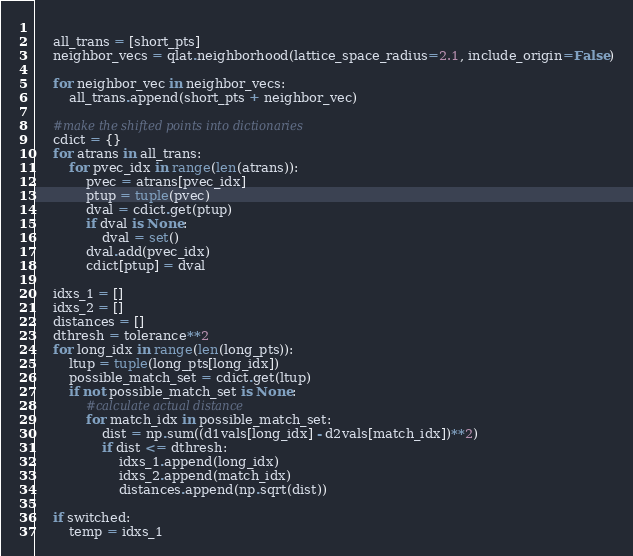<code> <loc_0><loc_0><loc_500><loc_500><_Python_>    
    all_trans = [short_pts]
    neighbor_vecs = qlat.neighborhood(lattice_space_radius=2.1, include_origin=False)
    
    for neighbor_vec in neighbor_vecs:
        all_trans.append(short_pts + neighbor_vec)
    
    #make the shifted points into dictionaries
    cdict = {}
    for atrans in all_trans:
        for pvec_idx in range(len(atrans)):
            pvec = atrans[pvec_idx]
            ptup = tuple(pvec)
            dval = cdict.get(ptup)
            if dval is None:
                dval = set()
            dval.add(pvec_idx)
            cdict[ptup] = dval
    
    idxs_1 = []
    idxs_2 = []
    distances = []
    dthresh = tolerance**2
    for long_idx in range(len(long_pts)):
        ltup = tuple(long_pts[long_idx])
        possible_match_set = cdict.get(ltup)
        if not possible_match_set is None:
            #calculate actual distance
            for match_idx in possible_match_set:
                dist = np.sum((d1vals[long_idx] - d2vals[match_idx])**2)
                if dist <= dthresh:
                    idxs_1.append(long_idx)
                    idxs_2.append(match_idx)
                    distances.append(np.sqrt(dist))
    
    if switched:
        temp = idxs_1</code> 